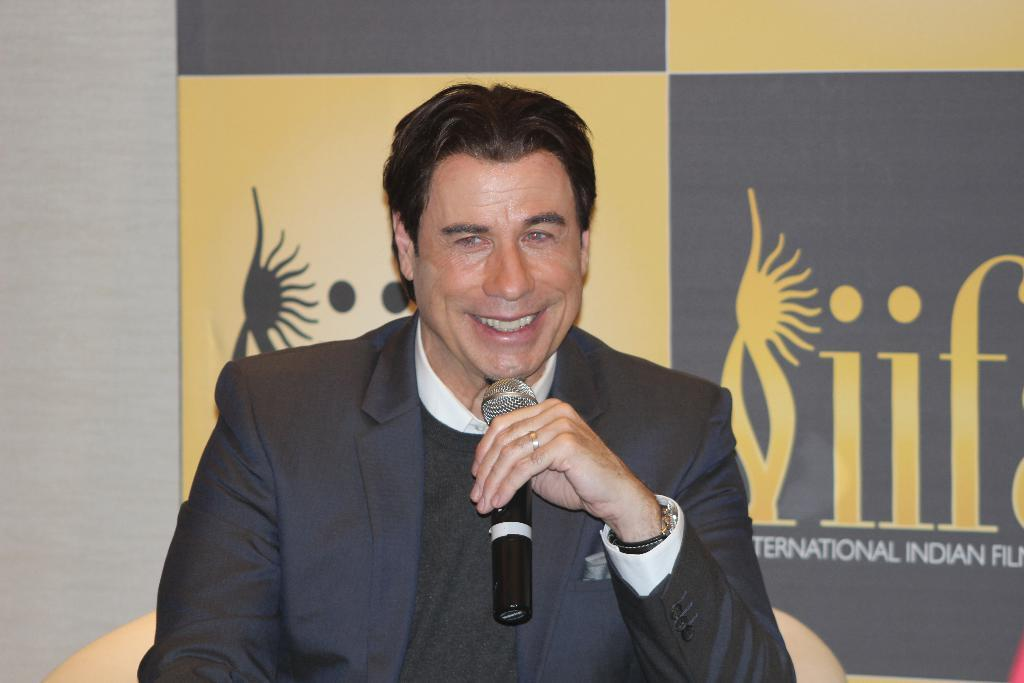What is the main subject of the image? The main subject of the image is a man sitting in the middle of the image. What is the man holding in the image? The man is holding a microphone. What is the man wearing in the image? The man is wearing a black coat. What expression does the man have in the image? The man is smiling in the image. What type of wood can be seen in the image? There is no wood present in the image. How many roses can be seen in the image? There are no roses present in the image. What type of scale is the man using to weigh the microphone in the image? There is no scale present in the image, and the man is not using any scale to weigh the microphone. 